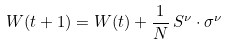<formula> <loc_0><loc_0><loc_500><loc_500>W ( t + 1 ) = W ( t ) + \frac { 1 } { N } \, S ^ { \nu } \cdot \sigma ^ { \nu }</formula> 